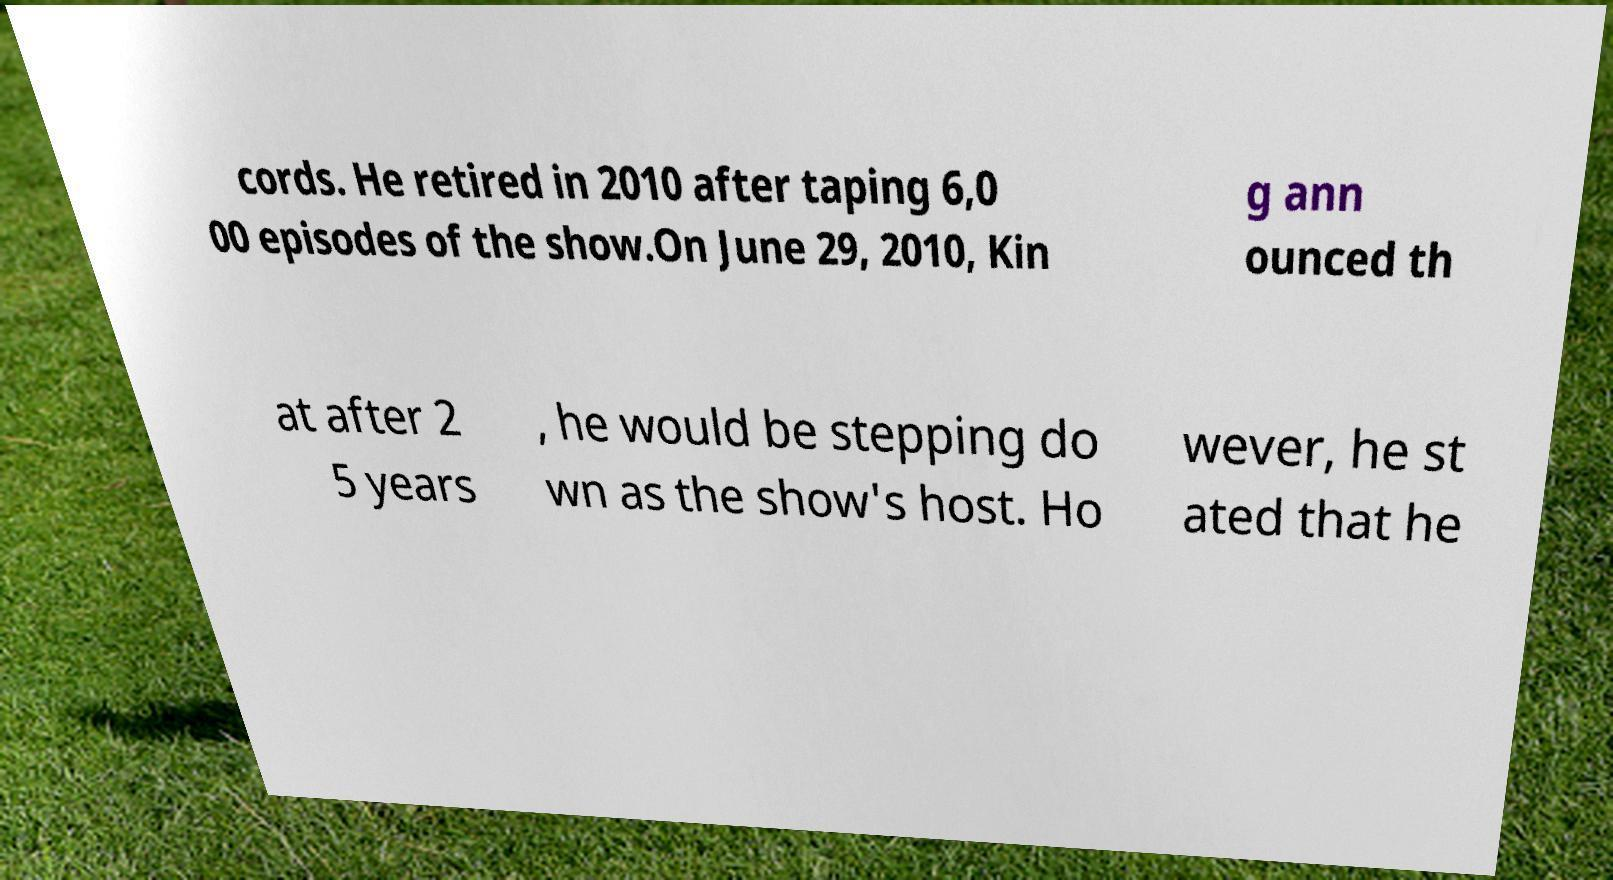Can you read and provide the text displayed in the image?This photo seems to have some interesting text. Can you extract and type it out for me? cords. He retired in 2010 after taping 6,0 00 episodes of the show.On June 29, 2010, Kin g ann ounced th at after 2 5 years , he would be stepping do wn as the show's host. Ho wever, he st ated that he 